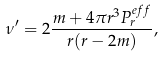<formula> <loc_0><loc_0><loc_500><loc_500>\nu ^ { \prime } = 2 \frac { m + 4 \pi r ^ { 3 } P ^ { e f f } _ { r } } { r ( r - 2 m ) } ,</formula> 